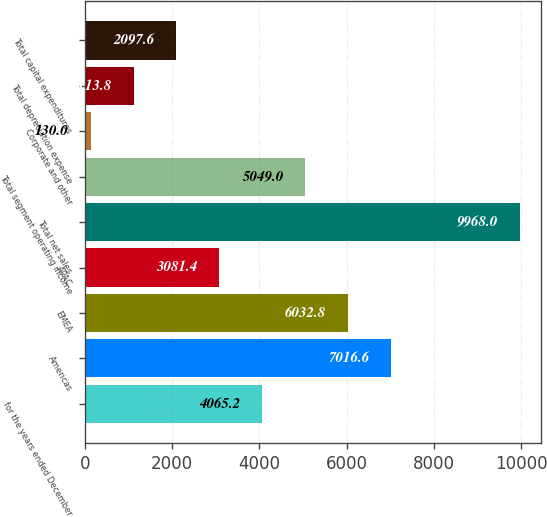Convert chart to OTSL. <chart><loc_0><loc_0><loc_500><loc_500><bar_chart><fcel>for the years ended December<fcel>Americas<fcel>EMEA<fcel>APAC<fcel>Total net sales<fcel>Total segment operating income<fcel>Corporate and other<fcel>Total depreciation expense<fcel>Total capital expenditures<nl><fcel>4065.2<fcel>7016.6<fcel>6032.8<fcel>3081.4<fcel>9968<fcel>5049<fcel>130<fcel>1113.8<fcel>2097.6<nl></chart> 